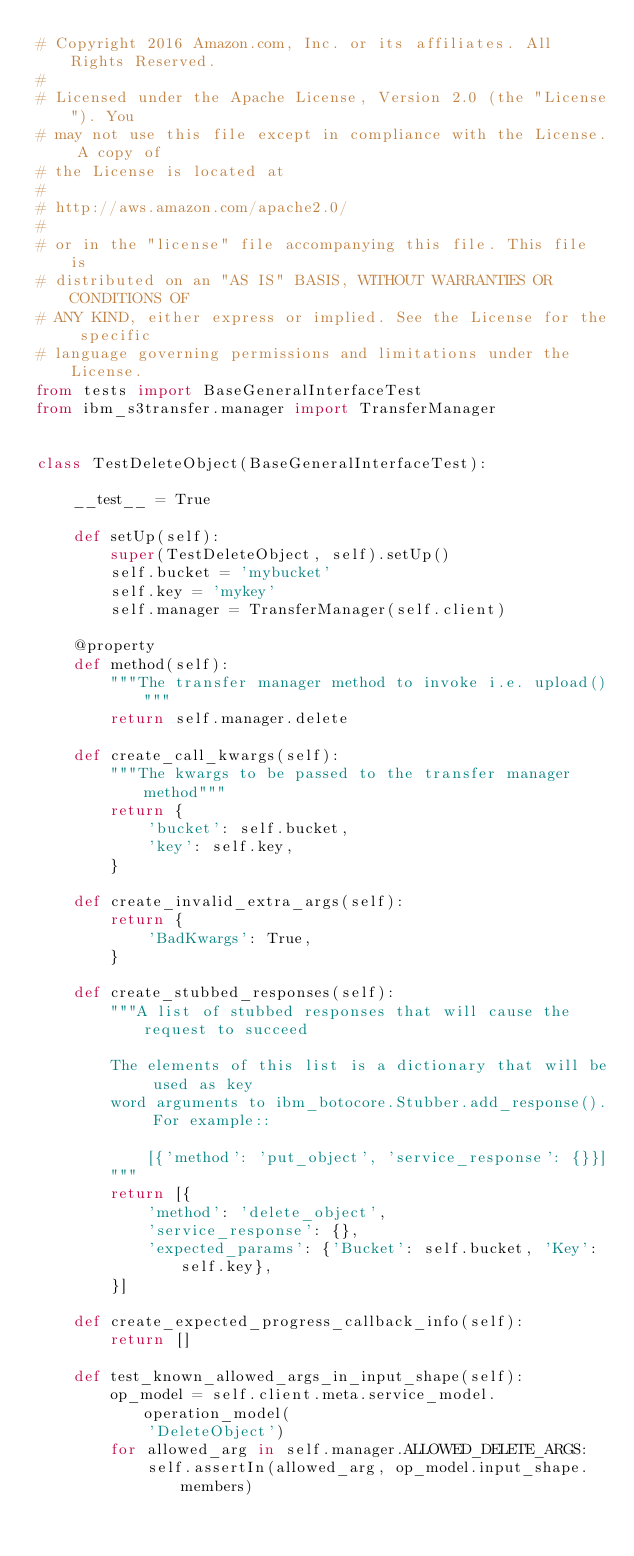<code> <loc_0><loc_0><loc_500><loc_500><_Python_># Copyright 2016 Amazon.com, Inc. or its affiliates. All Rights Reserved.
#
# Licensed under the Apache License, Version 2.0 (the "License"). You
# may not use this file except in compliance with the License. A copy of
# the License is located at
#
# http://aws.amazon.com/apache2.0/
#
# or in the "license" file accompanying this file. This file is
# distributed on an "AS IS" BASIS, WITHOUT WARRANTIES OR CONDITIONS OF
# ANY KIND, either express or implied. See the License for the specific
# language governing permissions and limitations under the License.
from tests import BaseGeneralInterfaceTest
from ibm_s3transfer.manager import TransferManager


class TestDeleteObject(BaseGeneralInterfaceTest):

    __test__ = True

    def setUp(self):
        super(TestDeleteObject, self).setUp()
        self.bucket = 'mybucket'
        self.key = 'mykey'
        self.manager = TransferManager(self.client)

    @property
    def method(self):
        """The transfer manager method to invoke i.e. upload()"""
        return self.manager.delete

    def create_call_kwargs(self):
        """The kwargs to be passed to the transfer manager method"""
        return {
            'bucket': self.bucket,
            'key': self.key,
        }

    def create_invalid_extra_args(self):
        return {
            'BadKwargs': True,
        }

    def create_stubbed_responses(self):
        """A list of stubbed responses that will cause the request to succeed

        The elements of this list is a dictionary that will be used as key
        word arguments to ibm_botocore.Stubber.add_response(). For example::

            [{'method': 'put_object', 'service_response': {}}]
        """
        return [{
            'method': 'delete_object',
            'service_response': {},
            'expected_params': {'Bucket': self.bucket, 'Key': self.key},
        }]

    def create_expected_progress_callback_info(self):
        return []

    def test_known_allowed_args_in_input_shape(self):
        op_model = self.client.meta.service_model.operation_model(
            'DeleteObject')
        for allowed_arg in self.manager.ALLOWED_DELETE_ARGS:
            self.assertIn(allowed_arg, op_model.input_shape.members)
</code> 